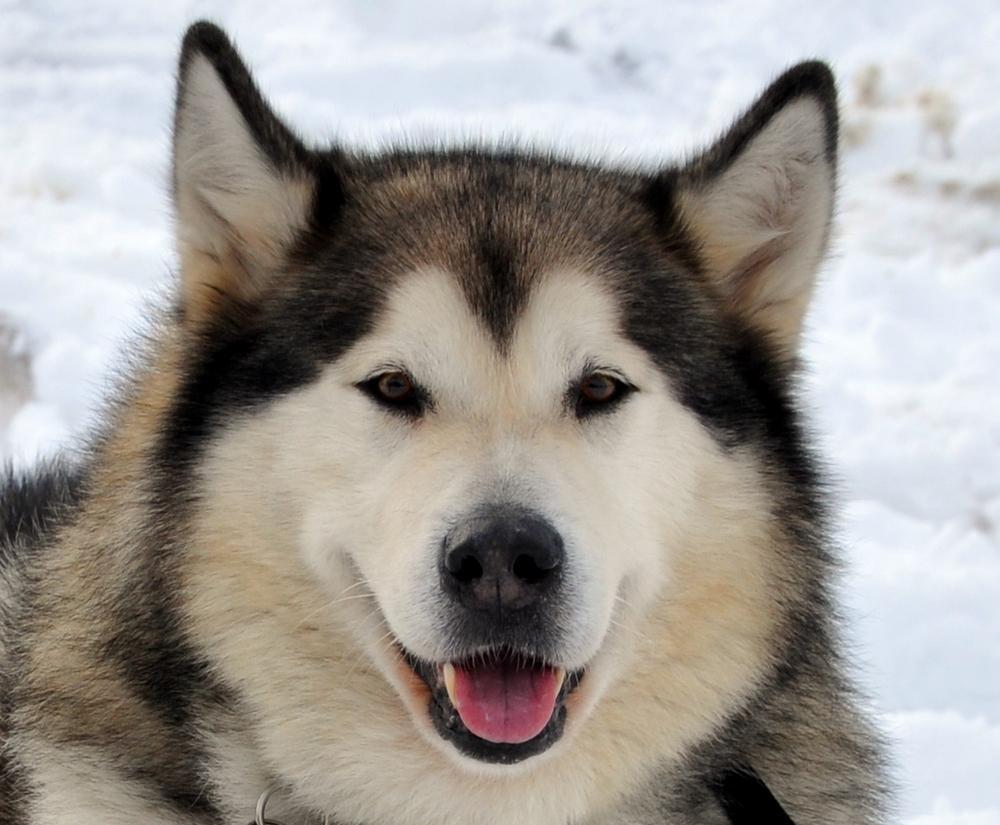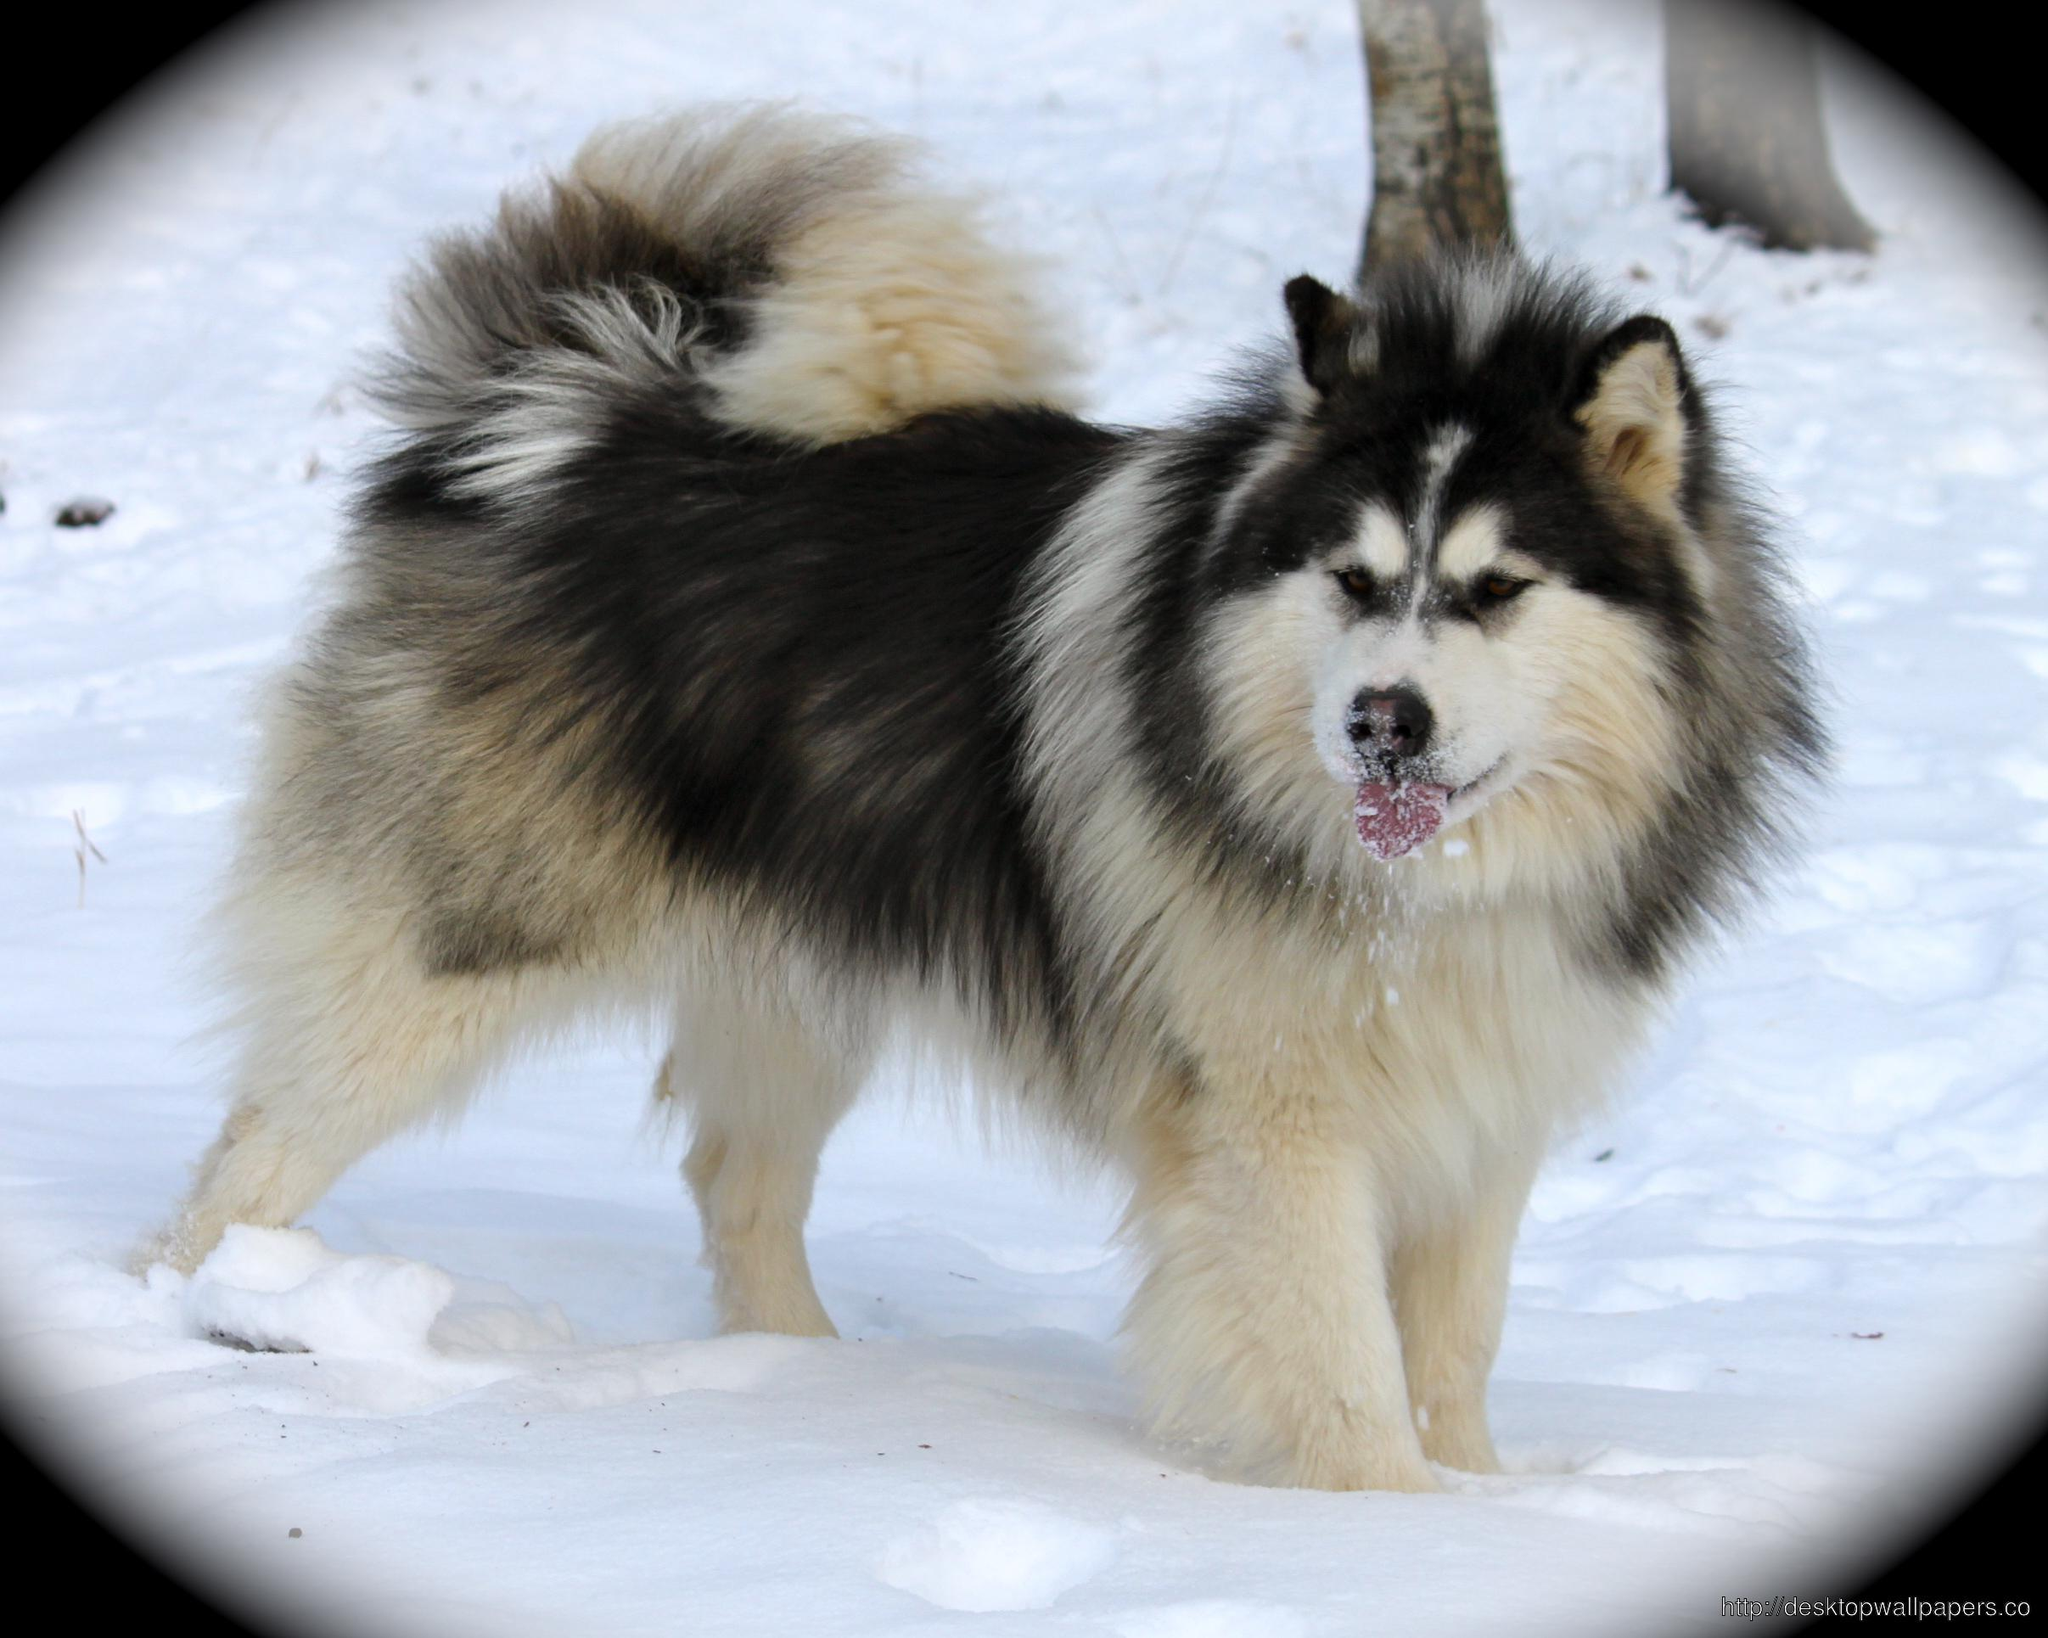The first image is the image on the left, the second image is the image on the right. Analyze the images presented: Is the assertion "There is exactly one dog outside in the snow in every photo, and both dogs either have their mouths closed or they both have them open." valid? Answer yes or no. Yes. The first image is the image on the left, the second image is the image on the right. Assess this claim about the two images: "The right image features a dog with dark fur framing a white-furred face and snow on some of its fur.". Correct or not? Answer yes or no. Yes. 